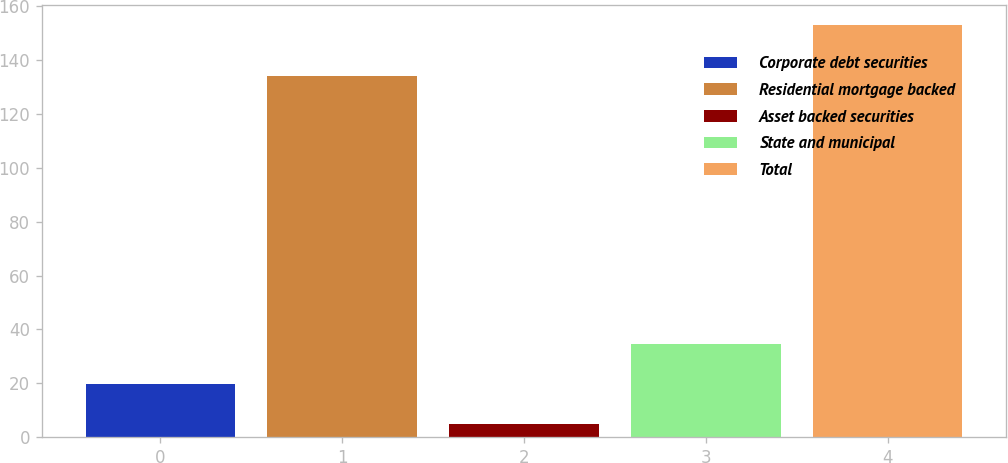Convert chart to OTSL. <chart><loc_0><loc_0><loc_500><loc_500><bar_chart><fcel>Corporate debt securities<fcel>Residential mortgage backed<fcel>Asset backed securities<fcel>State and municipal<fcel>Total<nl><fcel>19.8<fcel>134<fcel>5<fcel>34.6<fcel>153<nl></chart> 